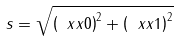Convert formula to latex. <formula><loc_0><loc_0><loc_500><loc_500>s = \sqrt { \left ( \ x x { 0 } \right ) ^ { 2 } + \left ( \ x x { 1 } \right ) ^ { 2 } }</formula> 